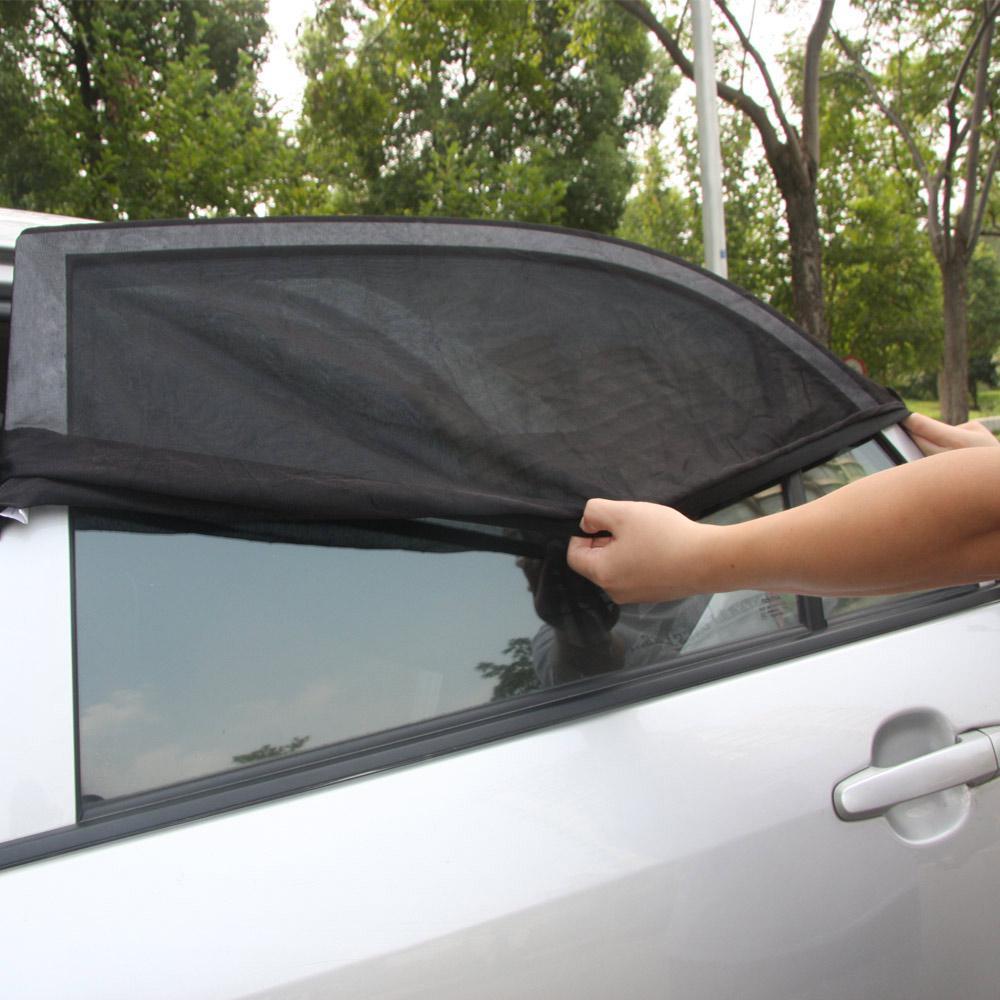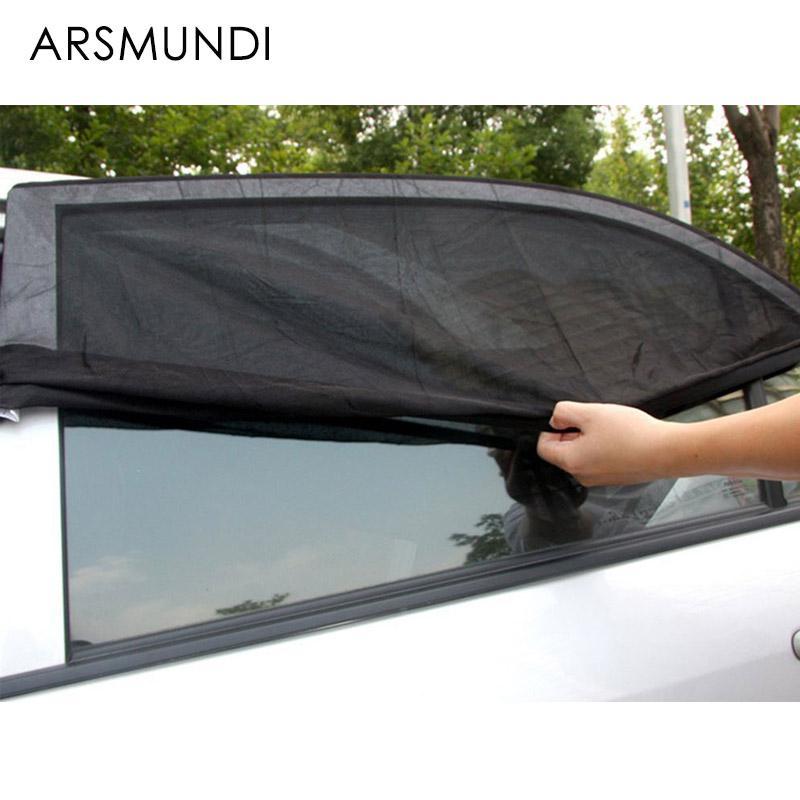The first image is the image on the left, the second image is the image on the right. Given the left and right images, does the statement "In at last one image, a person's hand is shown extending a car window shade." hold true? Answer yes or no. Yes. 